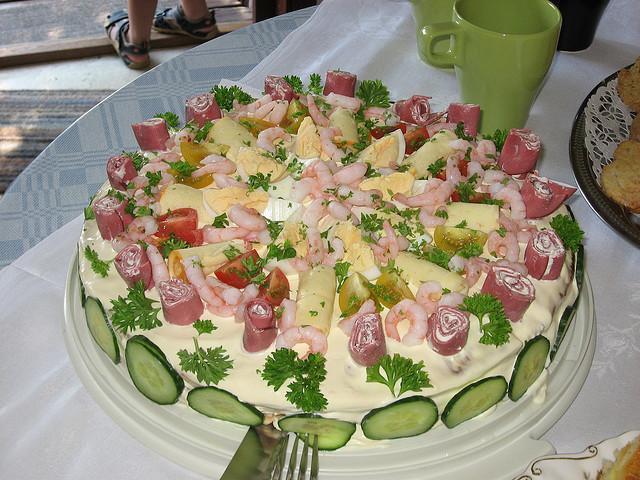Is the given caption "The pizza is opposite to the person." fitting for the image?
Answer yes or no. No. 